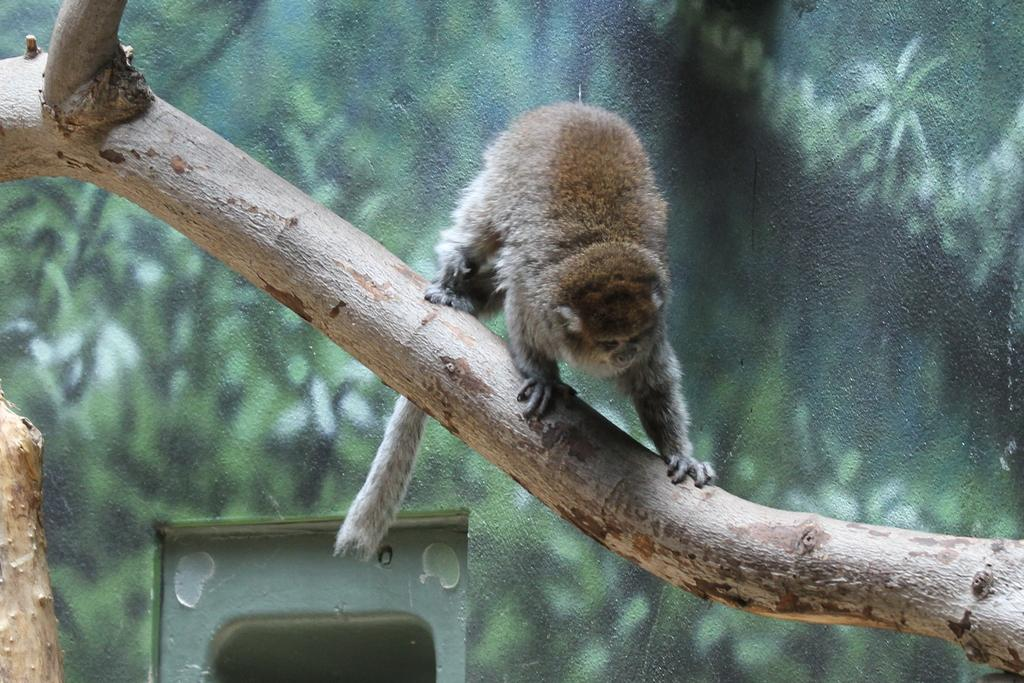Where was the image taken? The image was taken outdoors. What can be seen in the background of the image? There is a wall with a door in the background. What is in the middle of the image? There is a tree in the middle of the image. What is on the tree? There is a monkey on the tree. How does the monkey exchange powder with the tree in the image? There is no exchange of powder in the image; the monkey is simply sitting on the tree. 